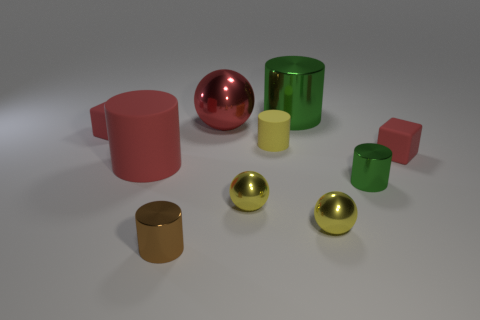How many red cubes must be subtracted to get 1 red cubes? 1 Subtract all small shiny spheres. How many spheres are left? 1 Subtract all cyan cylinders. How many yellow spheres are left? 2 Subtract all yellow cylinders. How many cylinders are left? 4 Subtract 1 blocks. How many blocks are left? 1 Subtract all blocks. How many objects are left? 8 Subtract all small metallic balls. Subtract all brown shiny cylinders. How many objects are left? 7 Add 7 yellow matte cylinders. How many yellow matte cylinders are left? 8 Add 7 big gray balls. How many big gray balls exist? 7 Subtract 0 blue spheres. How many objects are left? 10 